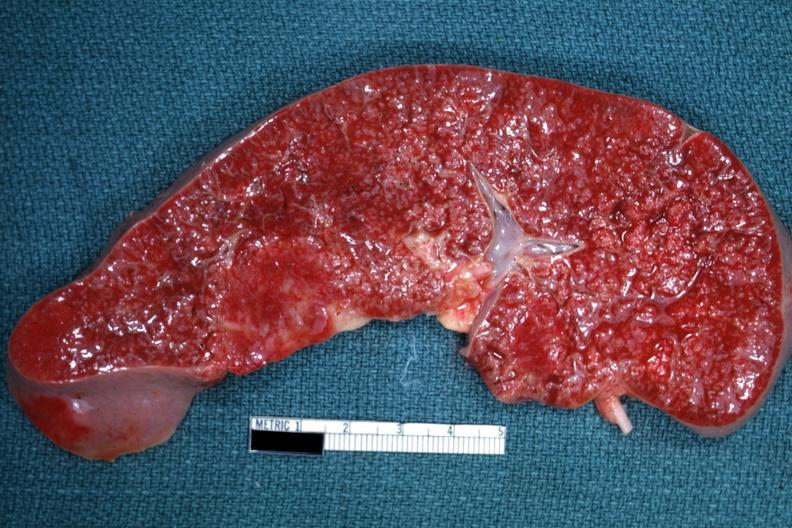how does this image show cut surface?
Answer the question using a single word or phrase. With multiple small infiltrates that simulate granulomata diagnosed as reticulum cell sarcoma 